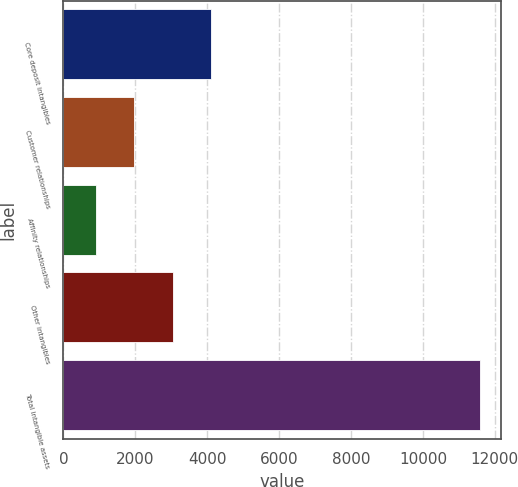Convert chart to OTSL. <chart><loc_0><loc_0><loc_500><loc_500><bar_chart><fcel>Core deposit intangibles<fcel>Customer relationships<fcel>Affinity relationships<fcel>Other intangibles<fcel>Total intangible assets<nl><fcel>4111.1<fcel>1971.7<fcel>902<fcel>3041.4<fcel>11599<nl></chart> 